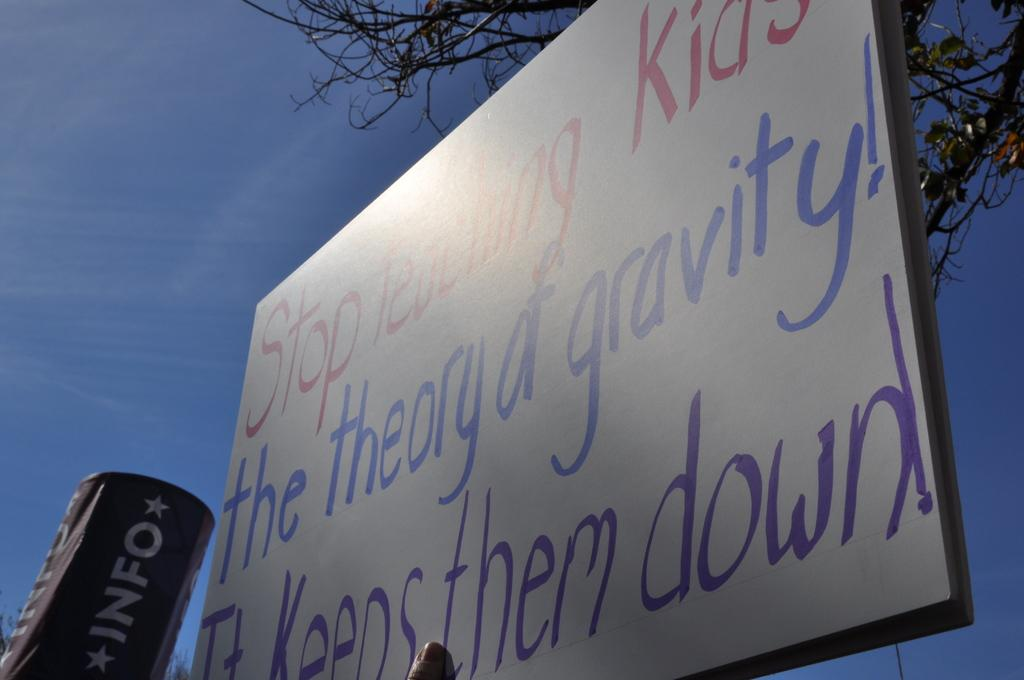What is the main object in the center of the image? There is a board in the center of the image. Can you identify any body parts in the image? Yes, a person's finger is visible in the image. What can be seen in the background of the image? There are trees and an object in the background of the image. What is visible above the board and trees in the image? The sky is visible in the image. What type of mist can be seen surrounding the board in the image? There is no mist present in the image; it is a clear scene with a board, a person's finger, trees, an object, and the sky visible. 